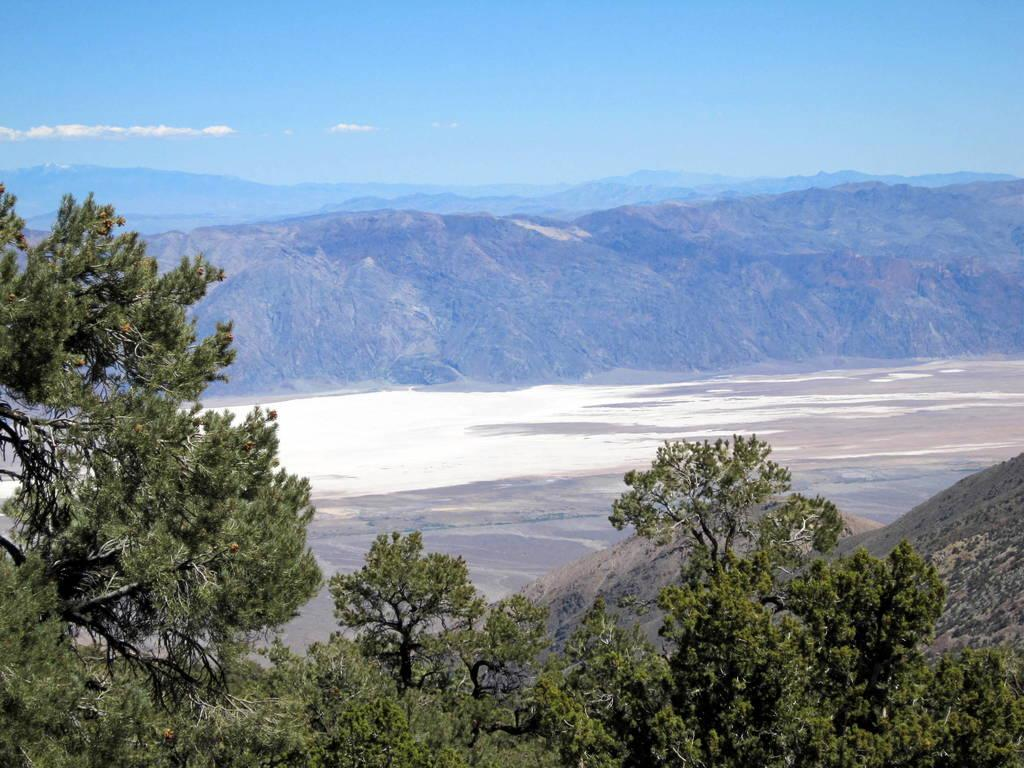What can be seen in the foreground of the image? There are trees and hills in the foreground of the image. What is visible in the background of the image? There are mountains and the sky in the background of the image. What can be observed in the sky? There are clouds in the sky. Can you tell me how many people are talking about their wounds in the image? There are no people or wounds present in the image; it features trees, hills, mountains, and clouds. What type of control is being exercised over the mountains in the image? There is no control being exercised over the mountains in the image; they are a natural formation. 